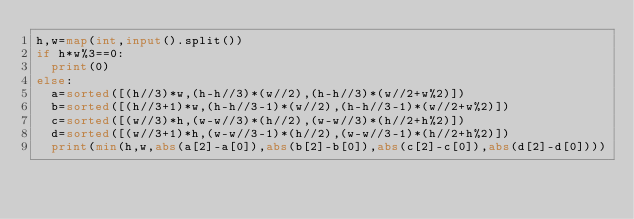Convert code to text. <code><loc_0><loc_0><loc_500><loc_500><_Python_>h,w=map(int,input().split())
if h*w%3==0:
  print(0)
else:
  a=sorted([(h//3)*w,(h-h//3)*(w//2),(h-h//3)*(w//2+w%2)])
  b=sorted([(h//3+1)*w,(h-h//3-1)*(w//2),(h-h//3-1)*(w//2+w%2)])
  c=sorted([(w//3)*h,(w-w//3)*(h//2),(w-w//3)*(h//2+h%2)])
  d=sorted([(w//3+1)*h,(w-w//3-1)*(h//2),(w-w//3-1)*(h//2+h%2)])
  print(min(h,w,abs(a[2]-a[0]),abs(b[2]-b[0]),abs(c[2]-c[0]),abs(d[2]-d[0])))</code> 